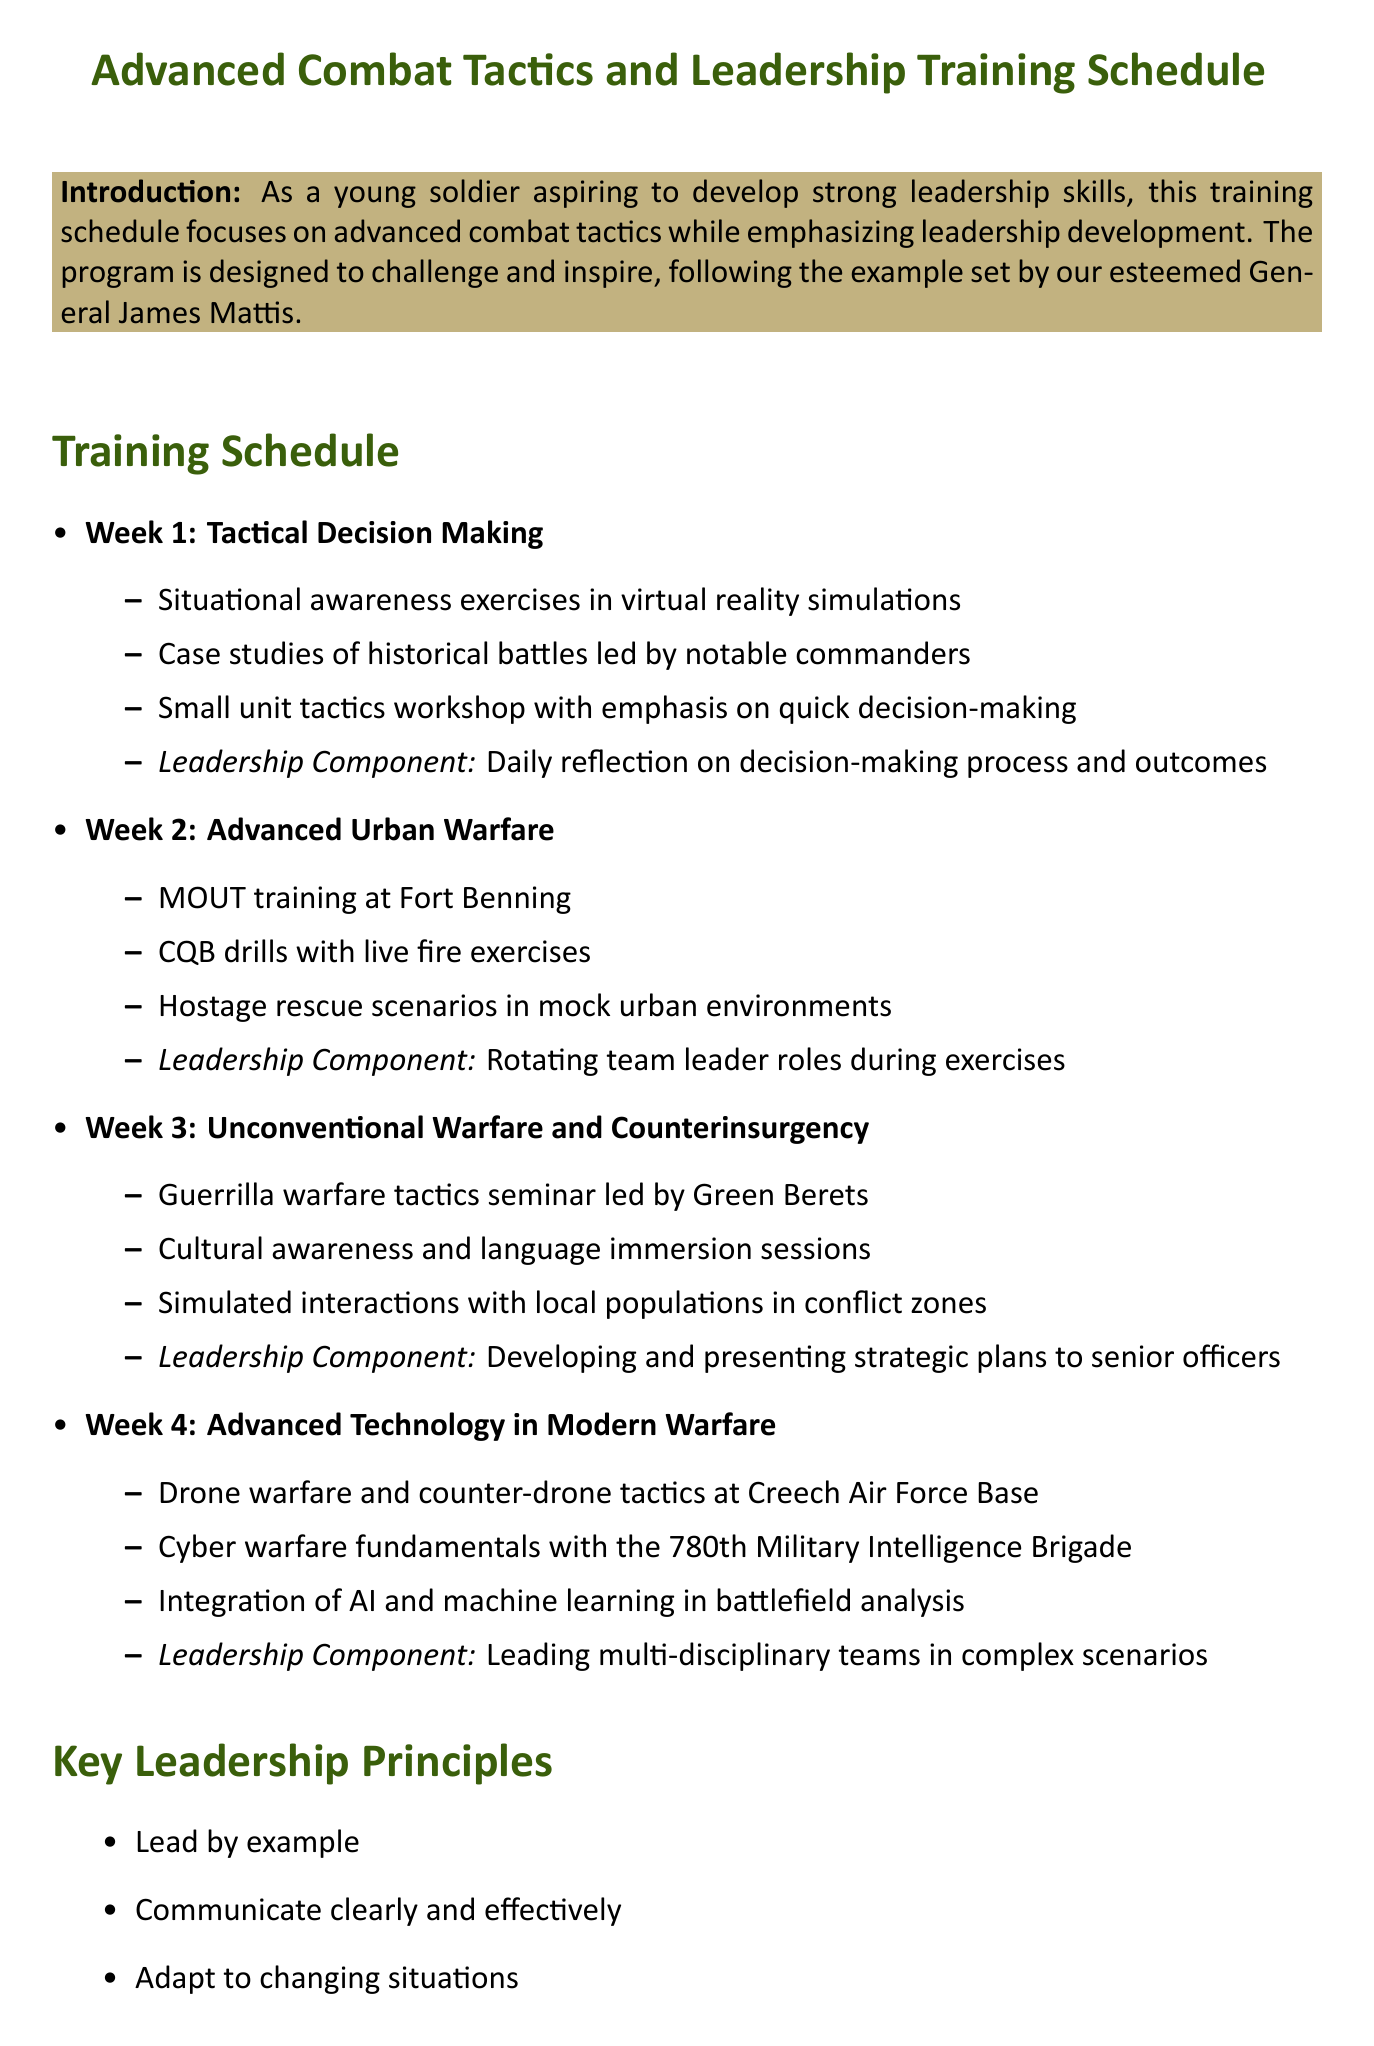What is the title of the memo? The title of the memo introduces the subject of advanced combat tactics and leadership training.
Answer: Advanced Combat Tactics and Leadership Training Schedule Who is the role model mentioned in the introduction? The introduction explicitly states the general who serves as a role model for leadership development in this training.
Answer: General James Mattis What is the focus of Week 3 in the training schedule? The training schedule outlines the focus for each week, and Week 3 is dedicated to a specific type of warfare.
Answer: Unconventional Warfare and Counterinsurgency What activity involves live fire exercises? The document includes various activities planned for the week focused on urban warfare and specifies one related to live fire.
Answer: CQB drills How many key leadership principles are listed? The number of key leadership principles is indicated in a bullet point format within the document.
Answer: Six What is the leadership component for Week 4? Each week contains a specific leadership component, and Week 4 includes a unique component that involves team leadership.
Answer: Leading multi-disciplinary teams in complex scenarios Which book is recommended reading by Jim Mattis? The recommended reading section lists books by various authors and identifies one specifically authored by Jim Mattis.
Answer: Call Sign Chaos: Learning to Lead What is emphasized as the most important aspect of leadership in the conclusion? The conclusion summarizes the essential takeaway regarding leadership, stating its core requirement.
Answer: Earning the trust and respect of those you lead 